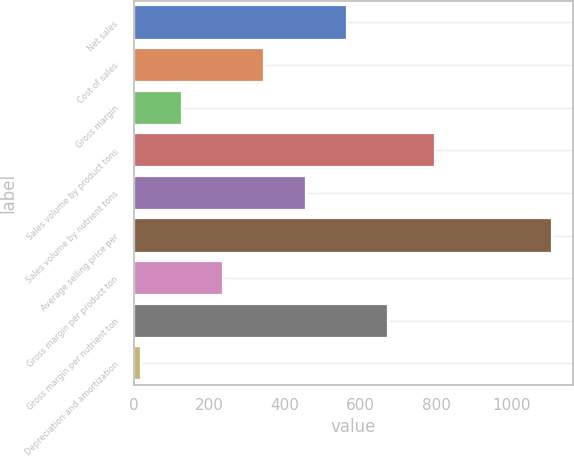Convert chart to OTSL. <chart><loc_0><loc_0><loc_500><loc_500><bar_chart><fcel>Net sales<fcel>Cost of sales<fcel>Gross margin<fcel>Sales volume by product tons<fcel>Sales volume by nutrient tons<fcel>Average selling price per<fcel>Gross margin per product ton<fcel>Gross margin per nutrient ton<fcel>Depreciation and amortization<nl><fcel>563.2<fcel>346.08<fcel>128.96<fcel>798<fcel>454.64<fcel>1106<fcel>237.52<fcel>671.76<fcel>20.4<nl></chart> 